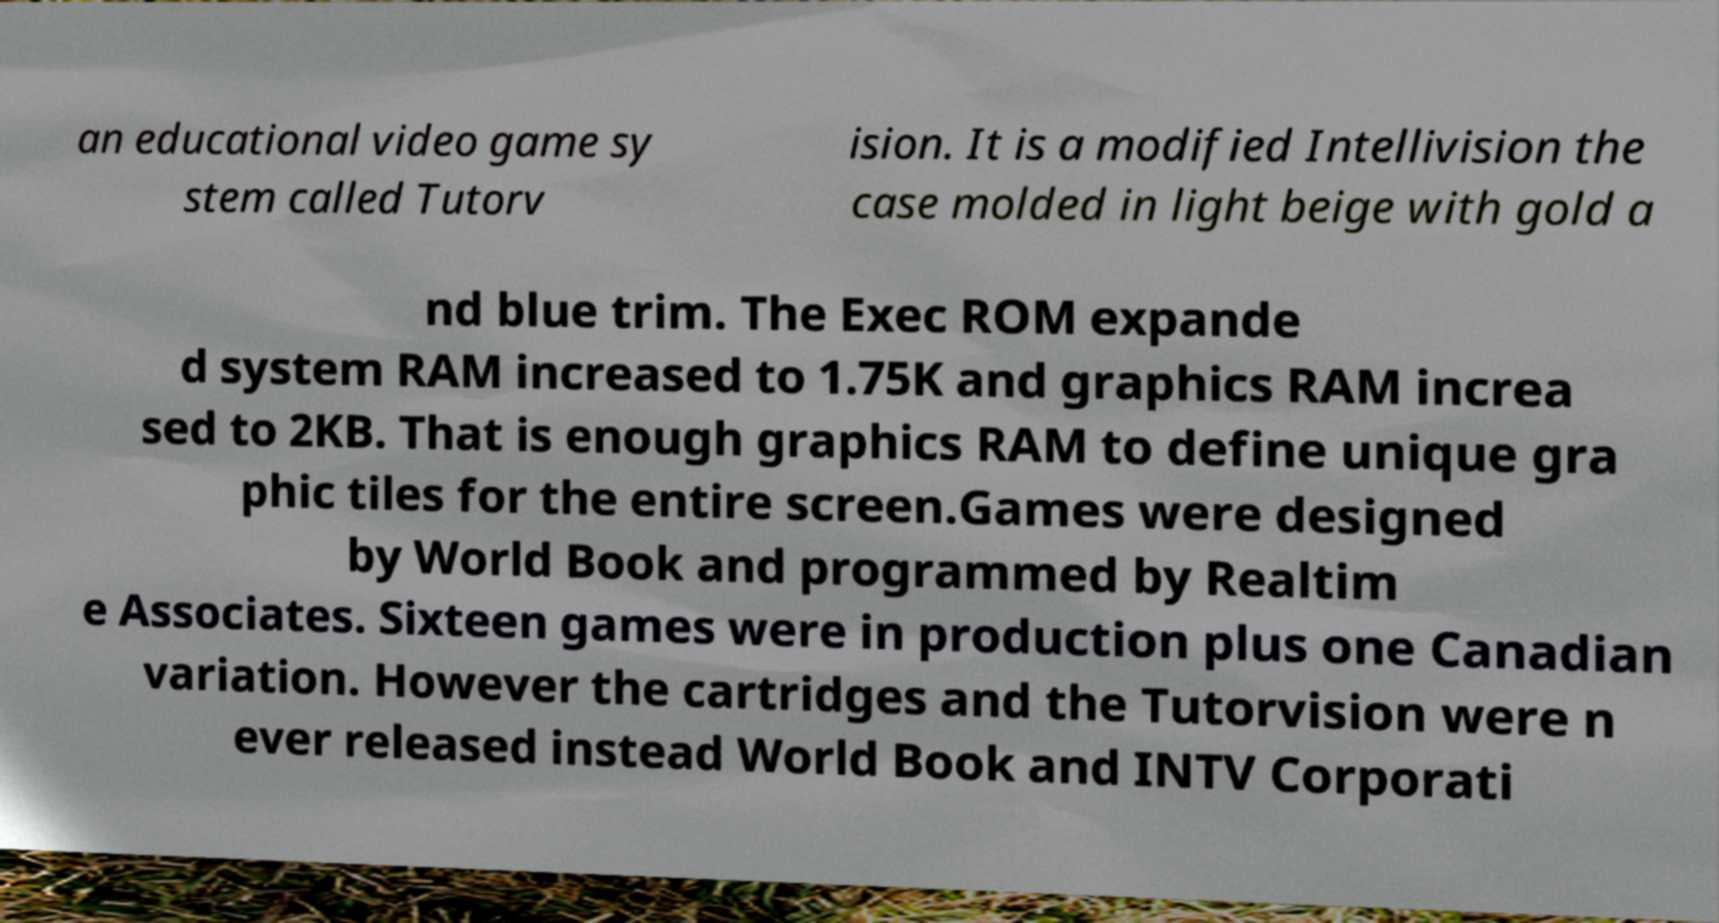Please read and relay the text visible in this image. What does it say? an educational video game sy stem called Tutorv ision. It is a modified Intellivision the case molded in light beige with gold a nd blue trim. The Exec ROM expande d system RAM increased to 1.75K and graphics RAM increa sed to 2KB. That is enough graphics RAM to define unique gra phic tiles for the entire screen.Games were designed by World Book and programmed by Realtim e Associates. Sixteen games were in production plus one Canadian variation. However the cartridges and the Tutorvision were n ever released instead World Book and INTV Corporati 